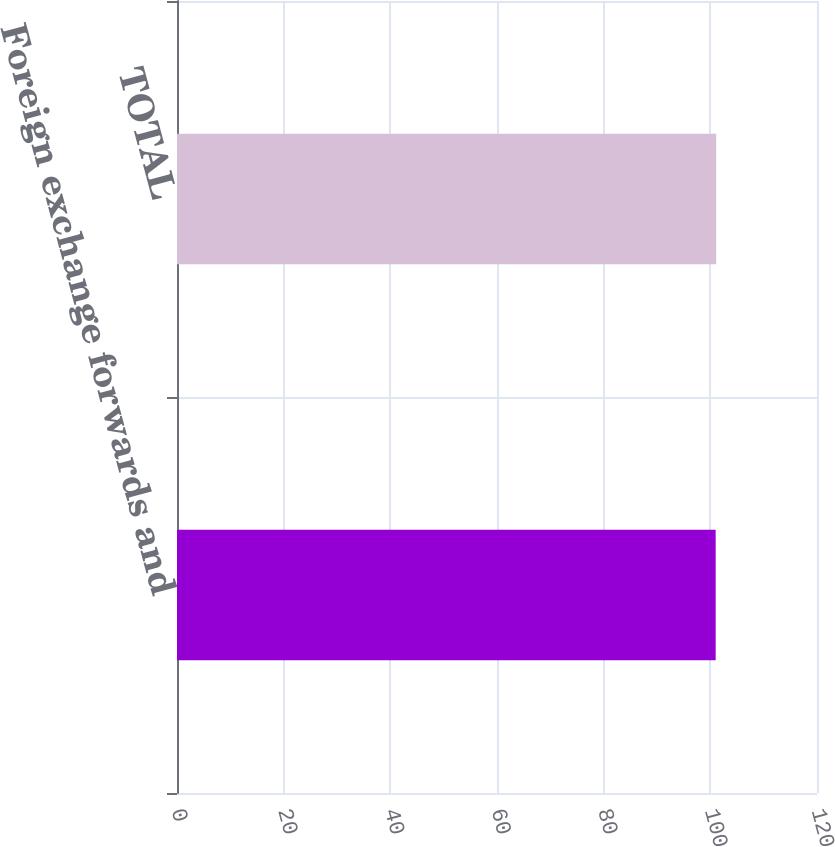<chart> <loc_0><loc_0><loc_500><loc_500><bar_chart><fcel>Foreign exchange forwards and<fcel>TOTAL<nl><fcel>101<fcel>101.1<nl></chart> 